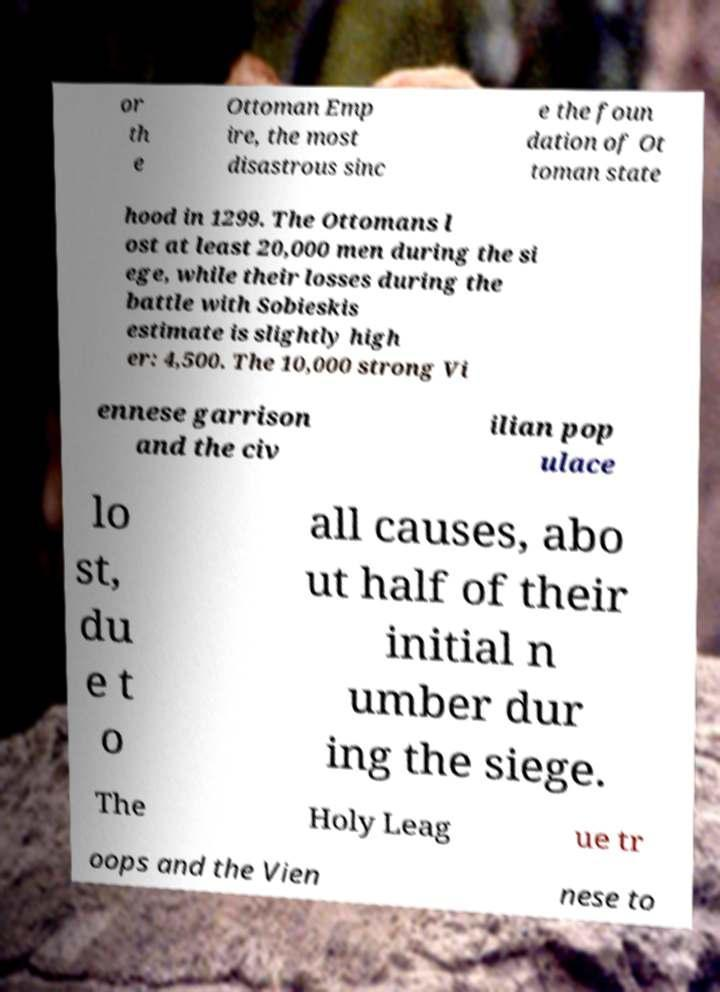I need the written content from this picture converted into text. Can you do that? or th e Ottoman Emp ire, the most disastrous sinc e the foun dation of Ot toman state hood in 1299. The Ottomans l ost at least 20,000 men during the si ege, while their losses during the battle with Sobieskis estimate is slightly high er: 4,500. The 10,000 strong Vi ennese garrison and the civ ilian pop ulace lo st, du e t o all causes, abo ut half of their initial n umber dur ing the siege. The Holy Leag ue tr oops and the Vien nese to 